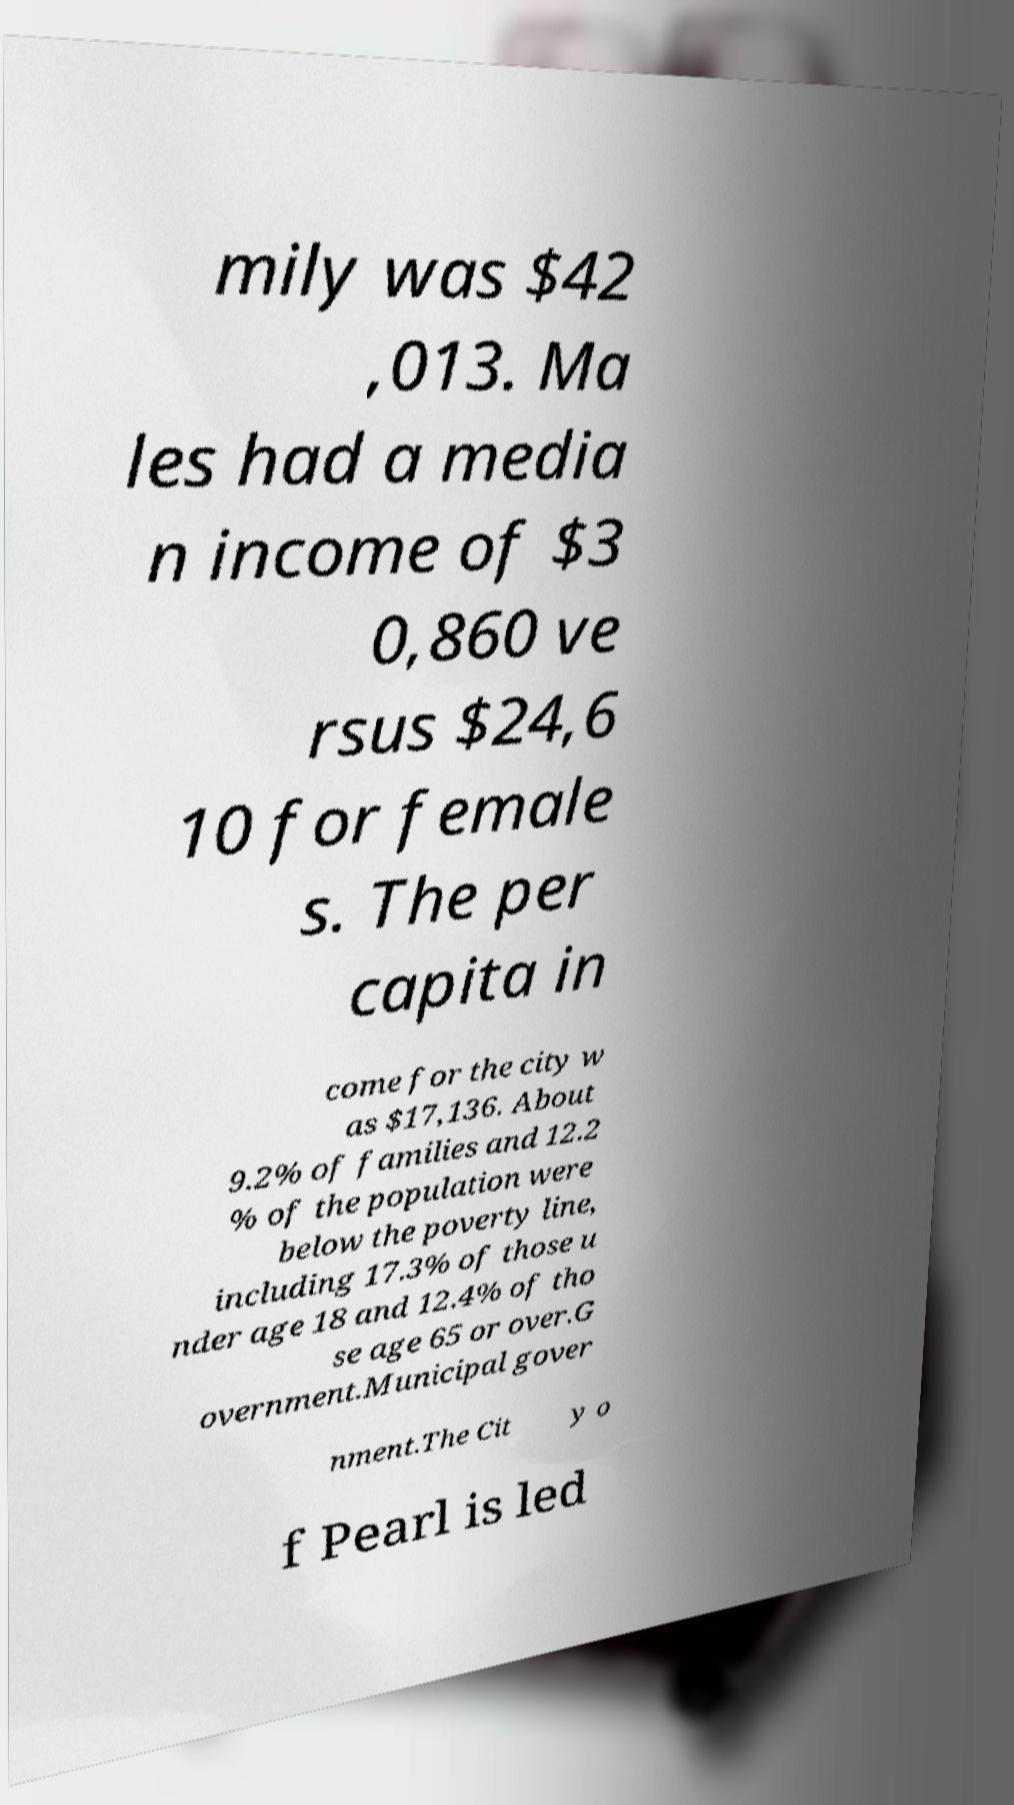What messages or text are displayed in this image? I need them in a readable, typed format. mily was $42 ,013. Ma les had a media n income of $3 0,860 ve rsus $24,6 10 for female s. The per capita in come for the city w as $17,136. About 9.2% of families and 12.2 % of the population were below the poverty line, including 17.3% of those u nder age 18 and 12.4% of tho se age 65 or over.G overnment.Municipal gover nment.The Cit y o f Pearl is led 